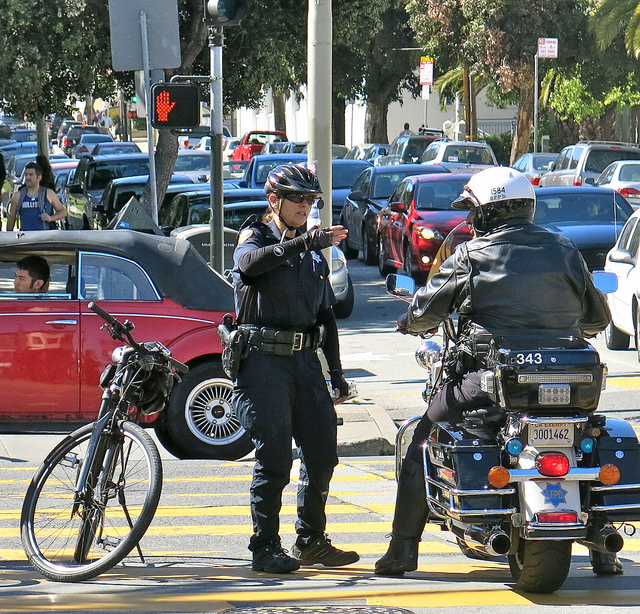What details in the image suggest this might be an urban setting? There are several urban indicators in this image: dense traffic, including numerous cars and a visible traffic signal showing a pedestrian 'Don't Walk' signal. The presence of the officers, tall buildings in the background, bicycles, and well-paved roads also contribute to the impression of an urban setting. Additionally, the style of the police uniforms and the motorcycle's design are consistent with what one might expect in a city environment. 